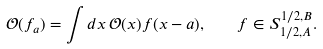<formula> <loc_0><loc_0><loc_500><loc_500>\mathcal { O } ( f _ { a } ) = \int d x \, \mathcal { O } ( x ) f ( x - a ) , \quad f \in S ^ { 1 / 2 , B } _ { 1 / 2 , A } .</formula> 